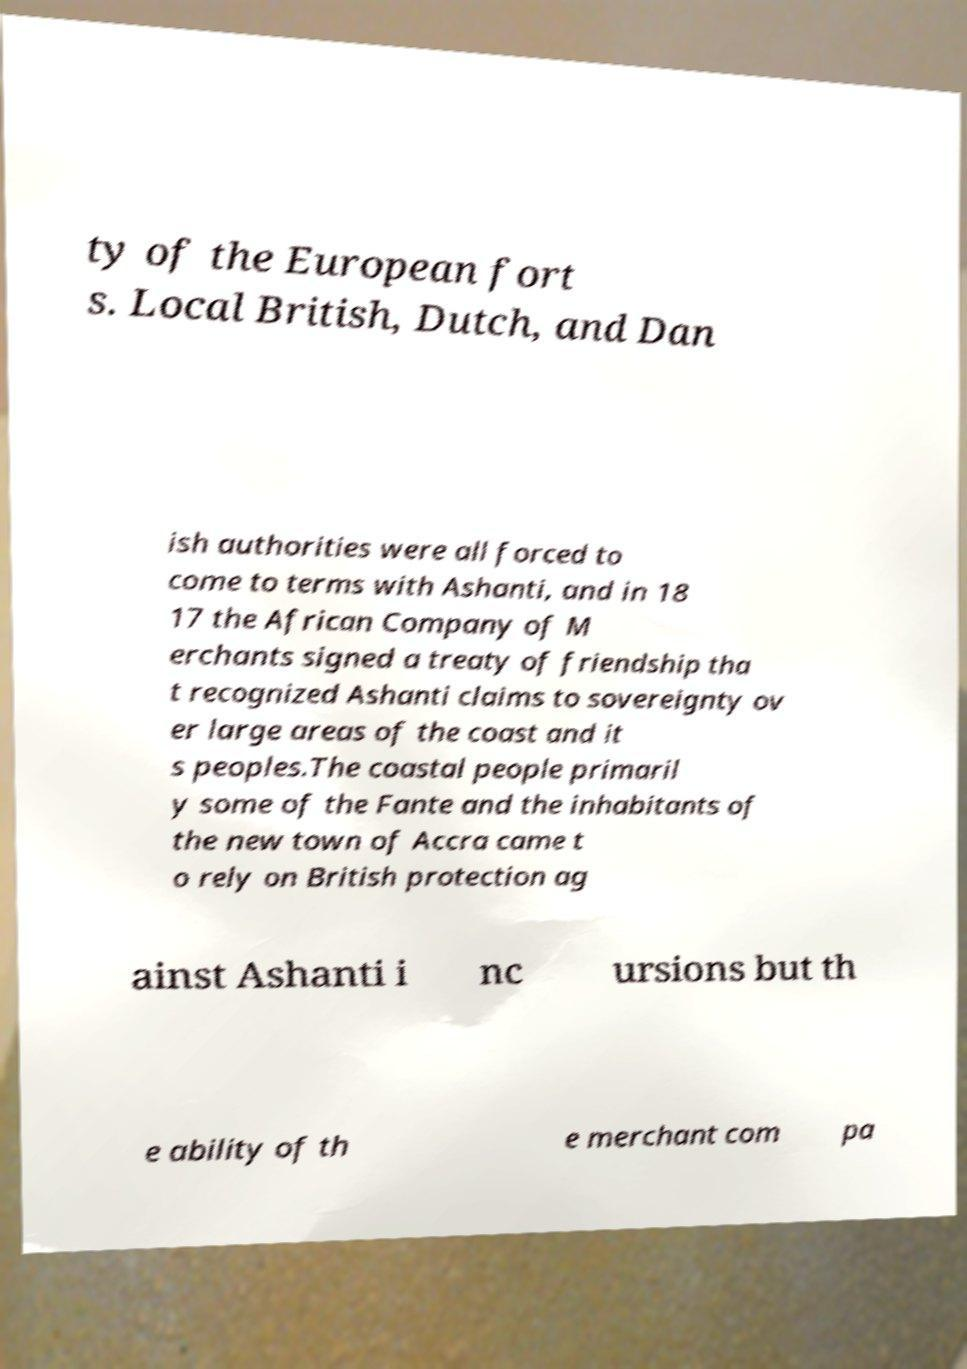What messages or text are displayed in this image? I need them in a readable, typed format. ty of the European fort s. Local British, Dutch, and Dan ish authorities were all forced to come to terms with Ashanti, and in 18 17 the African Company of M erchants signed a treaty of friendship tha t recognized Ashanti claims to sovereignty ov er large areas of the coast and it s peoples.The coastal people primaril y some of the Fante and the inhabitants of the new town of Accra came t o rely on British protection ag ainst Ashanti i nc ursions but th e ability of th e merchant com pa 